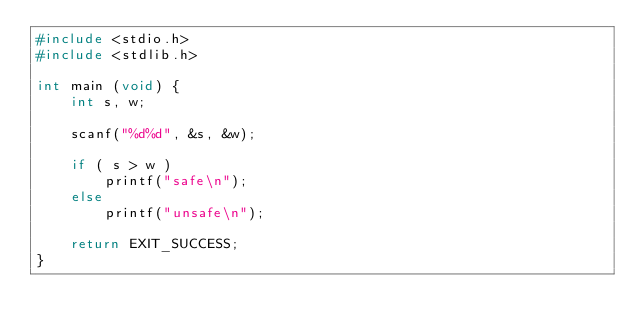Convert code to text. <code><loc_0><loc_0><loc_500><loc_500><_C_>#include <stdio.h>
#include <stdlib.h>

int main (void) {
    int s, w;

    scanf("%d%d", &s, &w);

    if ( s > w )
        printf("safe\n");
    else
        printf("unsafe\n");

    return EXIT_SUCCESS;
}
</code> 